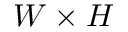<formula> <loc_0><loc_0><loc_500><loc_500>W \times H</formula> 